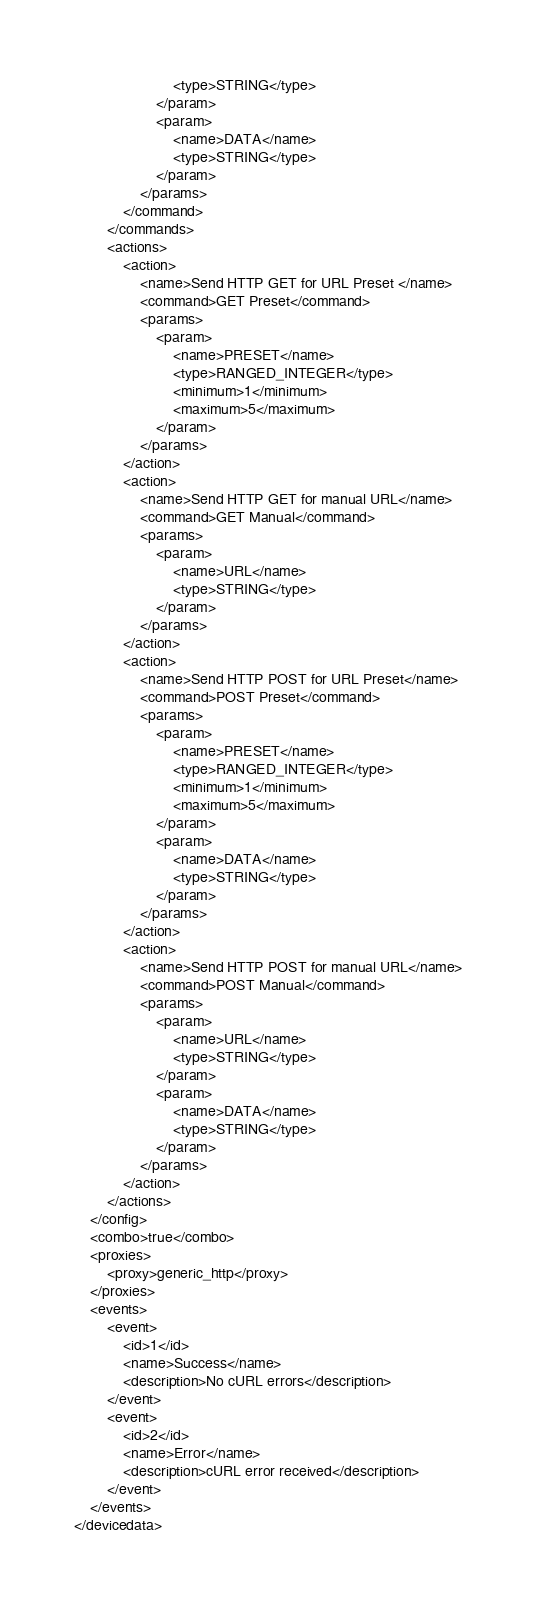Convert code to text. <code><loc_0><loc_0><loc_500><loc_500><_XML_>						<type>STRING</type>
					</param>
					<param>
						<name>DATA</name>
						<type>STRING</type>
					</param>
				</params>
			</command>
		</commands>
		<actions>
			<action>
				<name>Send HTTP GET for URL Preset </name>
				<command>GET Preset</command>
				<params>
					<param>
						<name>PRESET</name>
						<type>RANGED_INTEGER</type>
						<minimum>1</minimum>
						<maximum>5</maximum>
					</param>
				</params>
			</action>
			<action>
				<name>Send HTTP GET for manual URL</name>
				<command>GET Manual</command>
				<params>
					<param>
						<name>URL</name>
						<type>STRING</type>
					</param>
				</params>
			</action>
			<action>
				<name>Send HTTP POST for URL Preset</name>
				<command>POST Preset</command>
				<params>
					<param>
						<name>PRESET</name>
						<type>RANGED_INTEGER</type>
						<minimum>1</minimum>
						<maximum>5</maximum>
					</param>
					<param>
						<name>DATA</name>
						<type>STRING</type>
					</param>
				</params>
			</action>
			<action>
				<name>Send HTTP POST for manual URL</name>
				<command>POST Manual</command>
				<params>
					<param>
						<name>URL</name>
						<type>STRING</type>
					</param>
					<param>
						<name>DATA</name>
						<type>STRING</type>
					</param>
				</params>
			</action>
		</actions>
	</config>
	<combo>true</combo>
	<proxies>
		<proxy>generic_http</proxy>
	</proxies>
	<events>
		<event>
			<id>1</id>
			<name>Success</name>
			<description>No cURL errors</description>
		</event>
		<event>
			<id>2</id>
			<name>Error</name>
			<description>cURL error received</description>
		</event>
	</events>
</devicedata>
</code> 